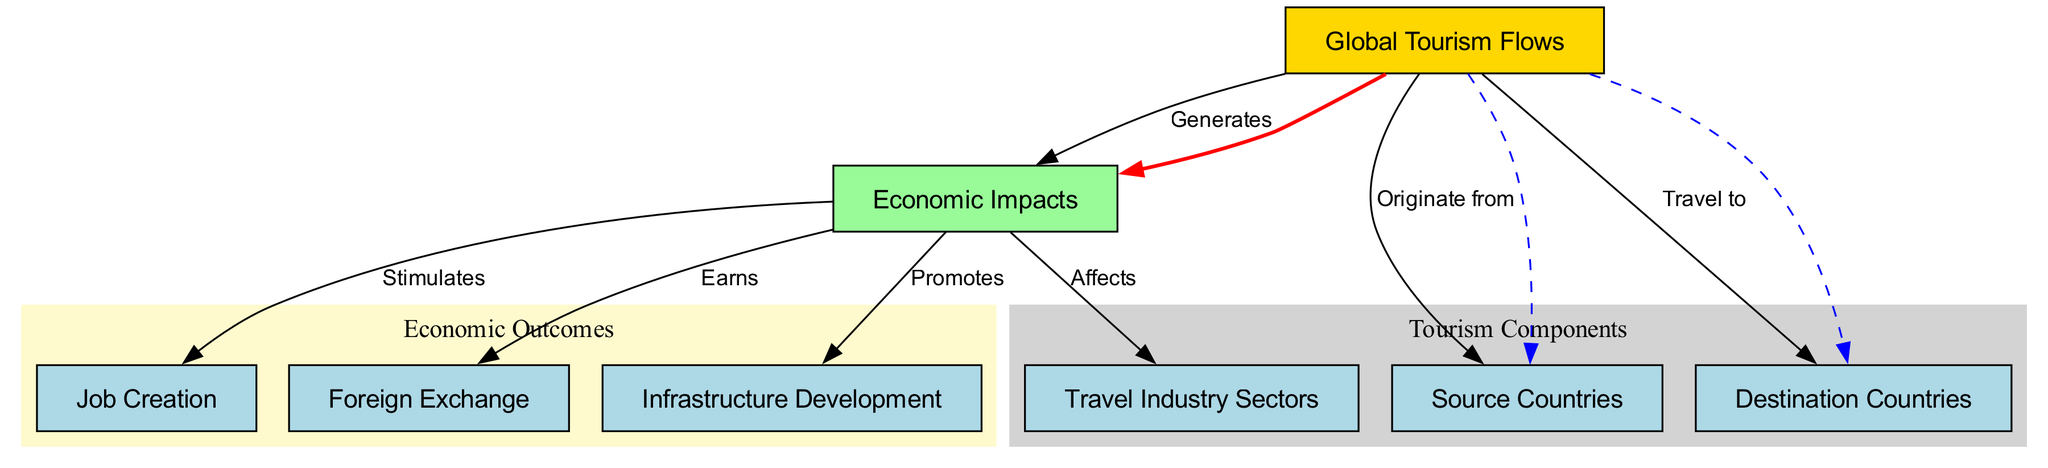What is the total number of nodes in the diagram? The diagram contains eight nodes, each representing a distinct concept related to global tourism flows and their economic implications.
Answer: Eight What does "Global Tourism Flows" generate? According to the diagram, "Global Tourism Flows" generates "Economic Impacts," demonstrating a direct relationship where tourism flows lead to economic outcomes.
Answer: Economic Impacts From which countries do tourism flows originate? The diagram indicates that tourism flows originate from "Source Countries," which are shown as one of the nodes connected to "Global Tourism Flows."
Answer: Source Countries Which sectors does "Economic Impacts" affect? The diagram shows that "Economic Impacts" affects the "Travel Industry Sectors," suggesting a direct influence of economic changes on various sectors within travel.
Answer: Travel Industry Sectors What does "Economic Impacts" stimulate? The diagram illustrates that "Economic Impacts" stimulates "Job Creation," indicating that economic changes from tourism flows result in increased job opportunities.
Answer: Job Creation What color represents "Global Tourism Flows"? In the diagram, "Global Tourism Flows" is represented using a gold color, clearly distinguishing it from other nodes.
Answer: Gold How does "Economic Impacts" influence foreign exchange? The diagram shows that "Economic Impacts" earns "Foreign Exchange," indicating that the economic consequences of tourism enhance the financial inflow from foreign sources.
Answer: Foreign Exchange Which node promotes infrastructure development? According to the diagram, "Economic Impacts" promotes "Infrastructure Development," demonstrating how tourism growth can lead to enhancements in a country's infrastructure.
Answer: Infrastructure Development What is the relationship between "Travel to" and "Destination Countries"? The diagram shows a dashed arrow indicating that "Global Tourism Flows" travel to "Destination Countries," signifying a connection where tourists move from source countries to specific destination countries.
Answer: Travel to Destination Countries 